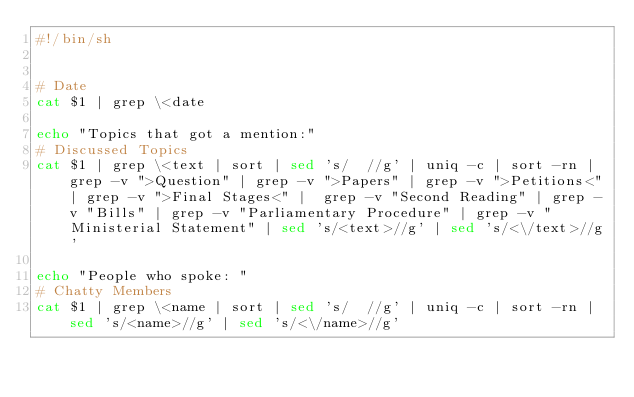Convert code to text. <code><loc_0><loc_0><loc_500><loc_500><_Bash_>#!/bin/sh


# Date 
cat $1 | grep \<date

echo "Topics that got a mention:"
# Discussed Topics
cat $1 | grep \<text | sort | sed 's/  //g' | uniq -c | sort -rn | grep -v ">Question" | grep -v ">Papers" | grep -v ">Petitions<"| grep -v ">Final Stages<" |  grep -v "Second Reading" | grep -v "Bills" | grep -v "Parliamentary Procedure" | grep -v "Ministerial Statement" | sed 's/<text>//g' | sed 's/<\/text>//g'

echo "People who spoke: " 
# Chatty Members
cat $1 | grep \<name | sort | sed 's/  //g' | uniq -c | sort -rn | sed 's/<name>//g' | sed 's/<\/name>//g'

</code> 